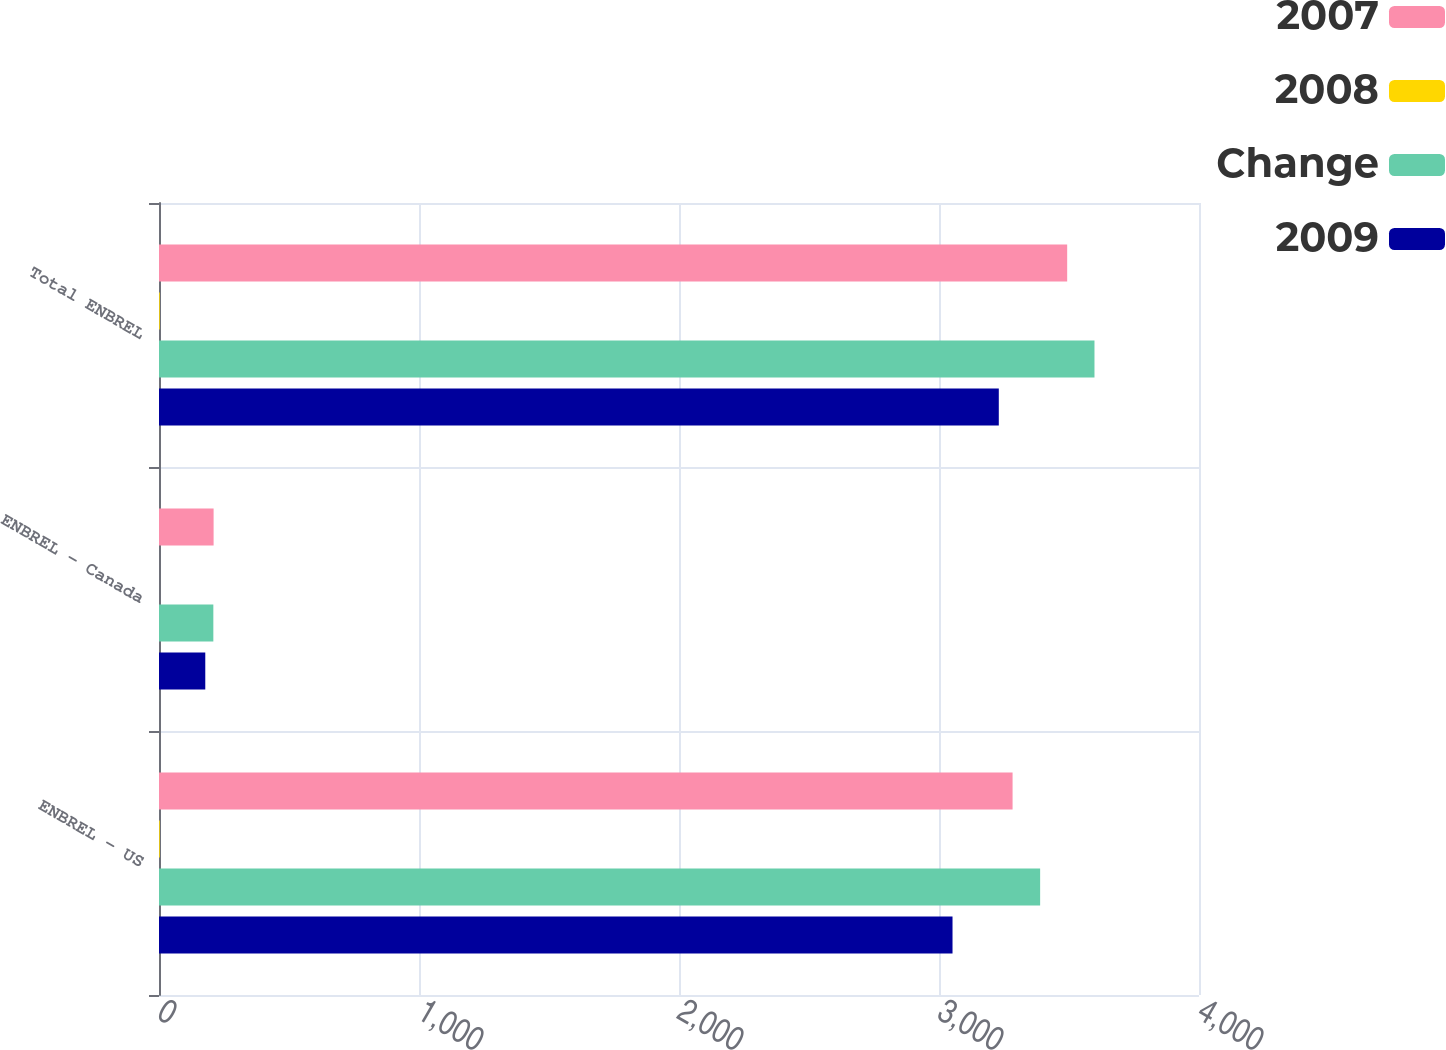<chart> <loc_0><loc_0><loc_500><loc_500><stacked_bar_chart><ecel><fcel>ENBREL - US<fcel>ENBREL - Canada<fcel>Total ENBREL<nl><fcel>2007<fcel>3283<fcel>210<fcel>3493<nl><fcel>2008<fcel>3<fcel>0<fcel>3<nl><fcel>Change<fcel>3389<fcel>209<fcel>3598<nl><fcel>2009<fcel>3052<fcel>178<fcel>3230<nl></chart> 